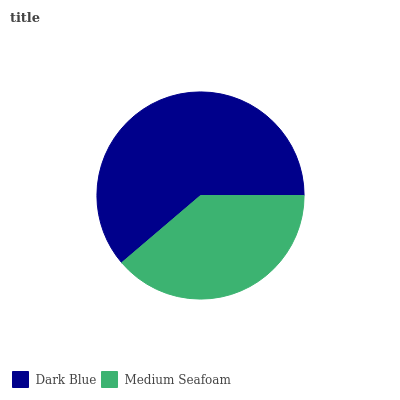Is Medium Seafoam the minimum?
Answer yes or no. Yes. Is Dark Blue the maximum?
Answer yes or no. Yes. Is Medium Seafoam the maximum?
Answer yes or no. No. Is Dark Blue greater than Medium Seafoam?
Answer yes or no. Yes. Is Medium Seafoam less than Dark Blue?
Answer yes or no. Yes. Is Medium Seafoam greater than Dark Blue?
Answer yes or no. No. Is Dark Blue less than Medium Seafoam?
Answer yes or no. No. Is Dark Blue the high median?
Answer yes or no. Yes. Is Medium Seafoam the low median?
Answer yes or no. Yes. Is Medium Seafoam the high median?
Answer yes or no. No. Is Dark Blue the low median?
Answer yes or no. No. 